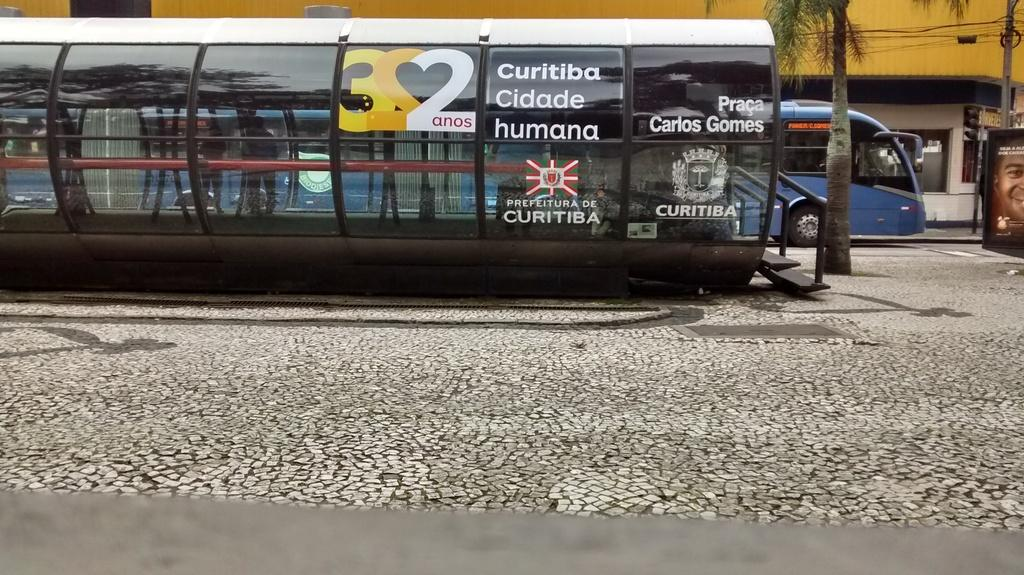<image>
Share a concise interpretation of the image provided. Curitiba is one of the sponsor for the advertising shown. 